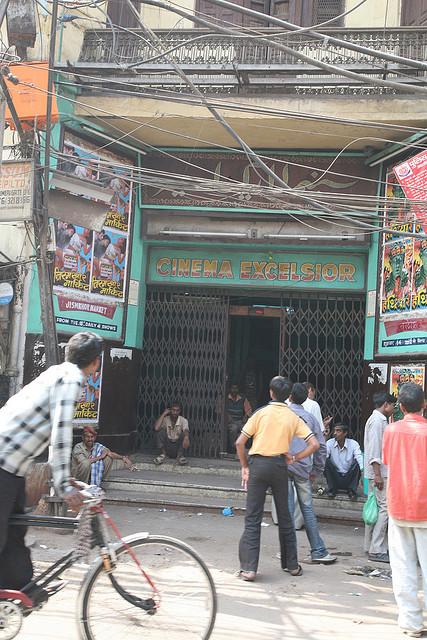Are the man's hands on the handlebar?
Give a very brief answer. Yes. Is this in America?
Concise answer only. No. What vehicles are shown?
Quick response, please. Bicycle. What language are the signs written in?
Write a very short answer. Spanish. What is going on here?
Quick response, please. Talking. Is the storefront open or closed?
Be succinct. Open. 